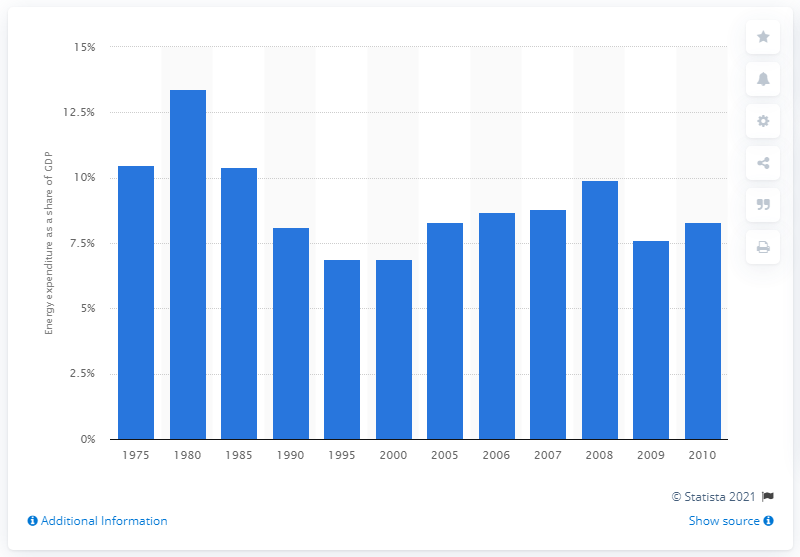Give some essential details in this illustration. In 2000, the energy expenditure relative to GDP was 6.9%. 